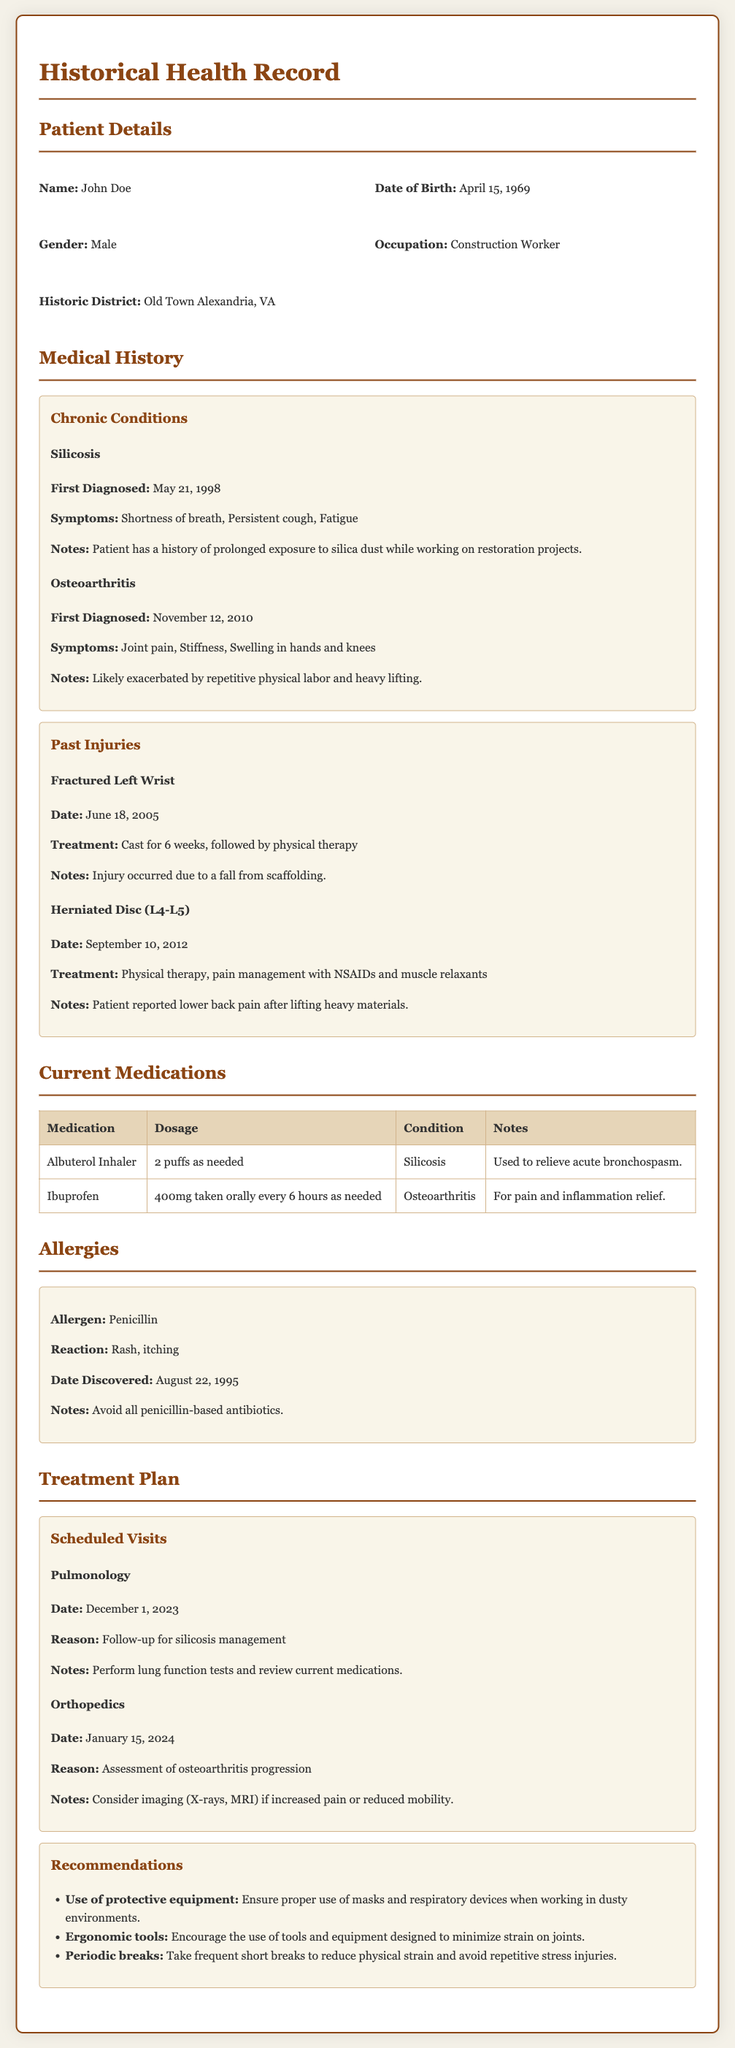What is the name of the patient? The patient's name is provided in the patient details section of the document.
Answer: John Doe What occupation does the patient have? The document specifies the patient's occupation under the patient details section.
Answer: Construction Worker When was the patient first diagnosed with silicosis? The date of the first diagnosis is listed under the medical history section for silicosis.
Answer: May 21, 1998 What allergy does the patient have? The document provides information about allergies in the allergies section.
Answer: Penicillin What treatment was given for the fractured left wrist? The treatment details are outlined in the past injuries section of the document.
Answer: Cast for 6 weeks, followed by physical therapy What is the reason for the upcoming pulmonology visit? The reason for the scheduled visit is specified in the treatment plan section under scheduled visits.
Answer: Follow-up for silicosis management How often is the patient instructed to take ibuprofen? The dosage instructions for ibuprofen can be found under current medications.
Answer: 400mg taken orally every 6 hours as needed What is one recommendation for the patient's work environment? Recommendations are listed in the treatment plan section, addressing safety in the work environment.
Answer: Ensure proper use of masks and respiratory devices when working in dusty environments On what date is the orthopedic assessment scheduled? The scheduled date for the orthopedic assessment is detailed in the treatment plan section.
Answer: January 15, 2024 